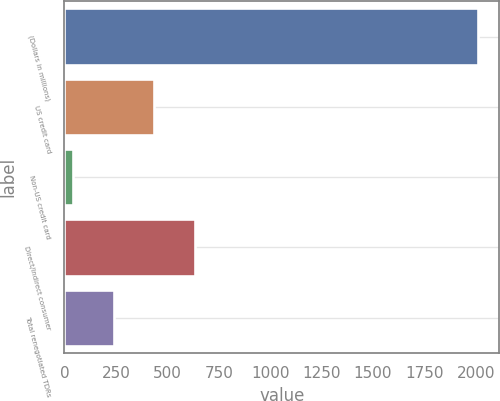<chart> <loc_0><loc_0><loc_500><loc_500><bar_chart><fcel>(Dollars in millions)<fcel>US credit card<fcel>Non-US credit card<fcel>Direct/Indirect consumer<fcel>Total renegotiated TDRs<nl><fcel>2012<fcel>437.37<fcel>43.71<fcel>634.2<fcel>240.54<nl></chart> 